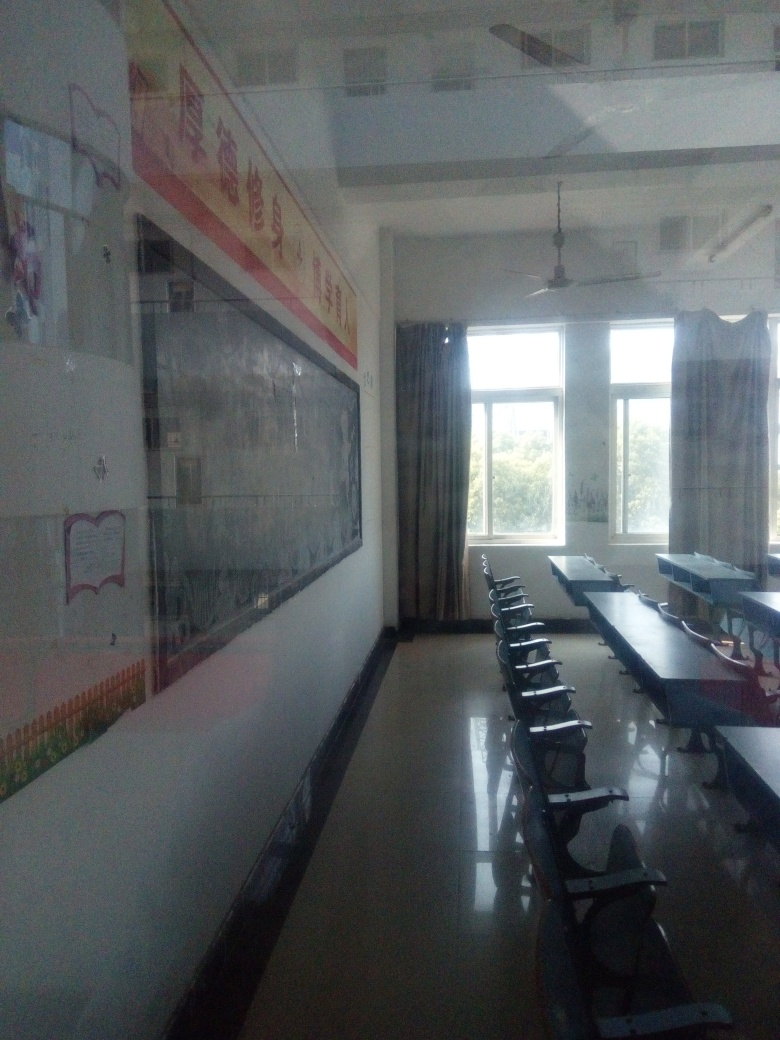Can you guess what time of day it is based on the lighting in the room? Based on the natural light coming through the windows and the absence of artificial light, it seems to be daytime, possibly morning or afternoon when classrooms are often filled with sunlight. 